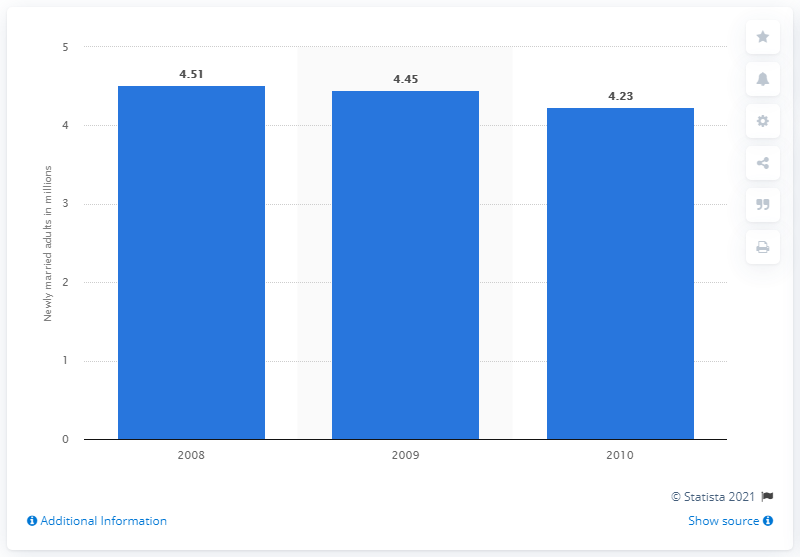Give some essential details in this illustration. In 2008, approximately 4.51 million adults in the United States got married. 